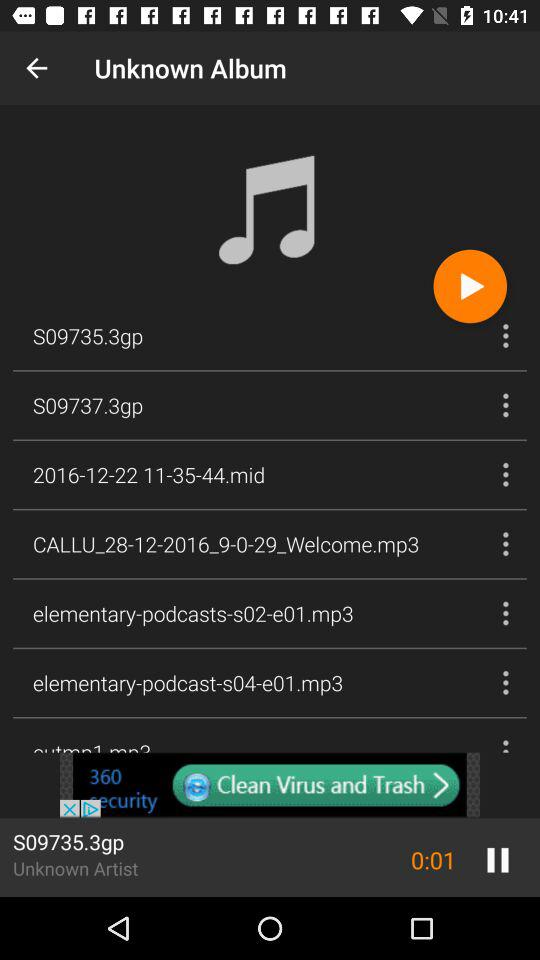Which video is playing? The video is "S09735.3gp". 